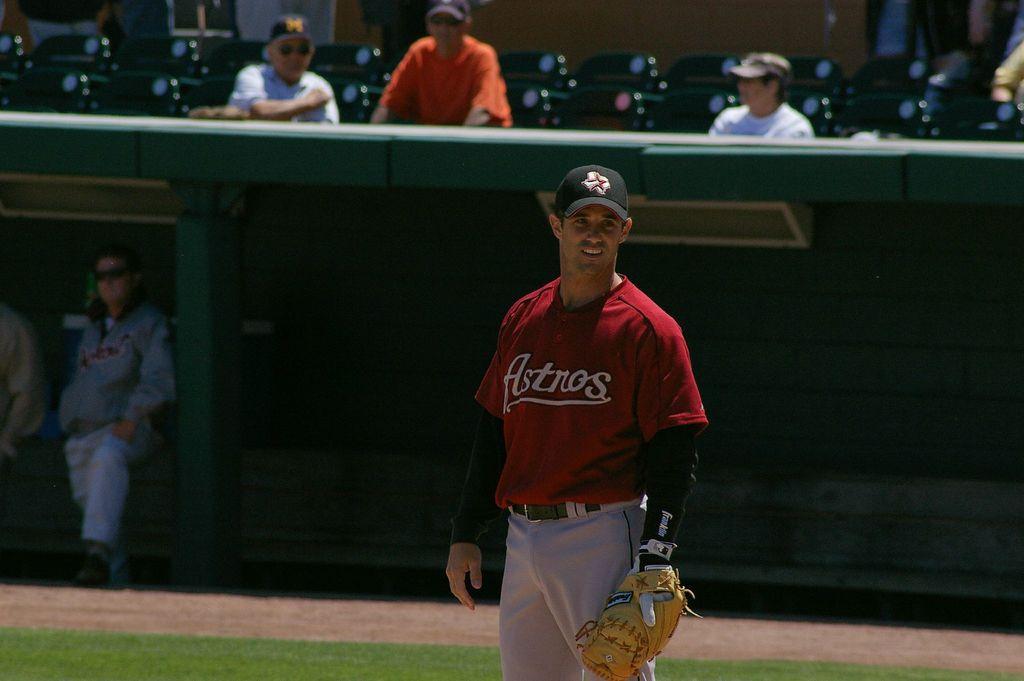What team is this player on?
Your answer should be compact. Astros. 